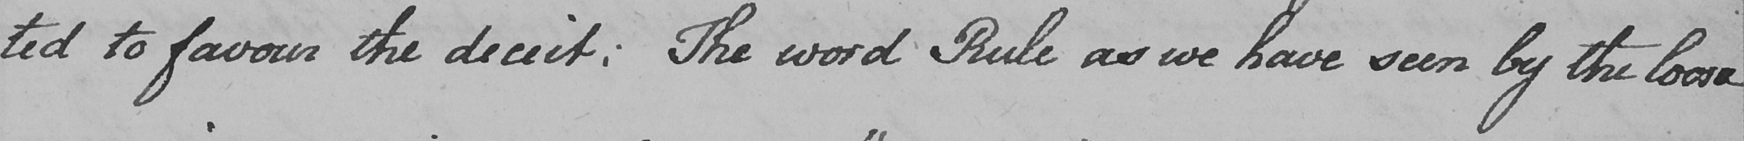Please provide the text content of this handwritten line. -ted to favour the deceit :  The word Rule as we have seen by the loose- 